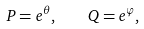<formula> <loc_0><loc_0><loc_500><loc_500>P = e ^ { \theta } , \quad Q = e ^ { \varphi } ,</formula> 